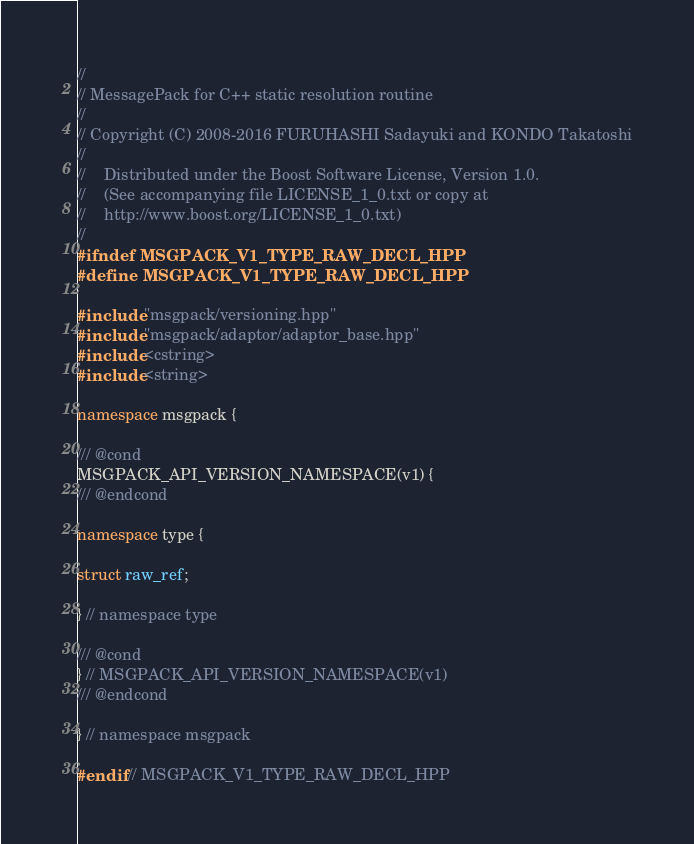<code> <loc_0><loc_0><loc_500><loc_500><_C++_>//
// MessagePack for C++ static resolution routine
//
// Copyright (C) 2008-2016 FURUHASHI Sadayuki and KONDO Takatoshi
//
//    Distributed under the Boost Software License, Version 1.0.
//    (See accompanying file LICENSE_1_0.txt or copy at
//    http://www.boost.org/LICENSE_1_0.txt)
//
#ifndef MSGPACK_V1_TYPE_RAW_DECL_HPP
#define MSGPACK_V1_TYPE_RAW_DECL_HPP

#include "msgpack/versioning.hpp"
#include "msgpack/adaptor/adaptor_base.hpp"
#include <cstring>
#include <string>

namespace msgpack {

/// @cond
MSGPACK_API_VERSION_NAMESPACE(v1) {
/// @endcond

namespace type {

struct raw_ref;

} // namespace type

/// @cond
} // MSGPACK_API_VERSION_NAMESPACE(v1)
/// @endcond

} // namespace msgpack

#endif // MSGPACK_V1_TYPE_RAW_DECL_HPP
</code> 